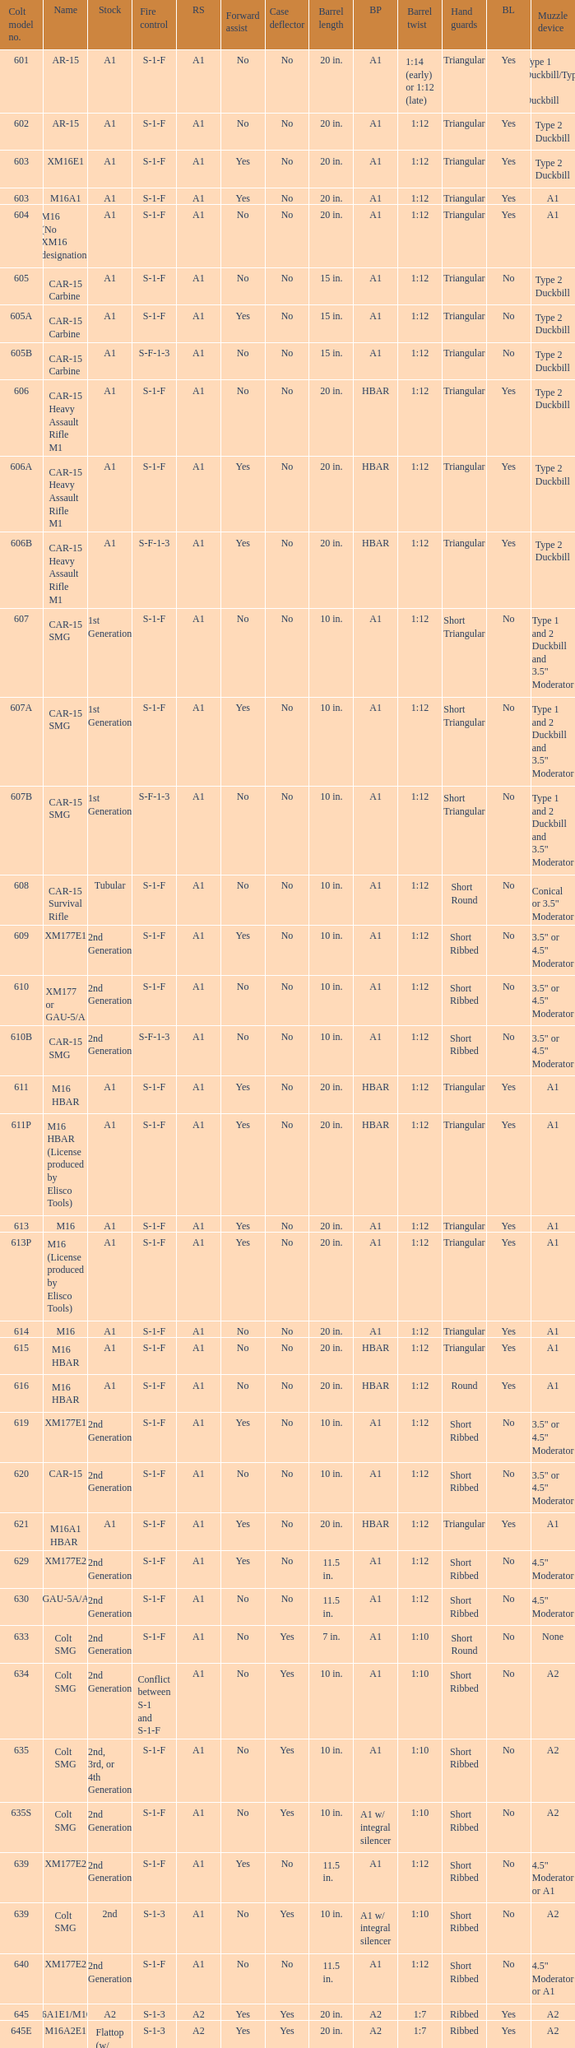What is the rear sight in the Cole model no. 735? A1 or A2. 